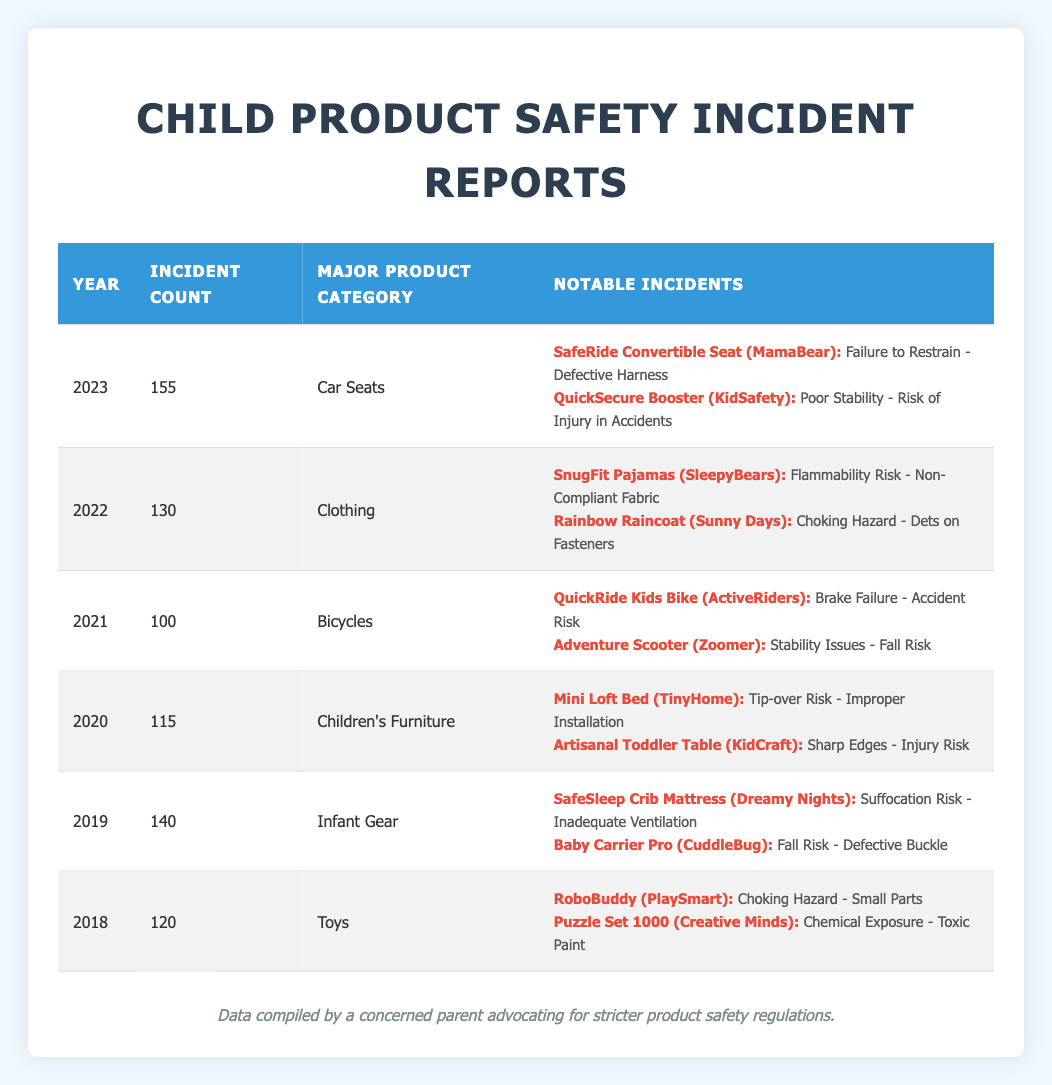What was the incident count for car seats in 2023? In the row for the year 2023, the incident count is listed as 155.
Answer: 155 Which product category had the highest incident count in 2023? The major product category for 2023 is "Car Seats," which had 155 incidents, making it the highest for that year.
Answer: Car Seats How many incident reports were there from 2018 to 2022 combined? To find the total for the years 2018 to 2022, we add the counts: 120 (2018) + 140 (2019) + 115 (2020) + 100 (2021) + 130 (2022) = 705.
Answer: 705 Did any notable incidents in 2021 involve a bicycle? Yes, in 2021, there were two notable incidents regarding bicycles: "QuickRide Kids Bike" and "Adventure Scooter."
Answer: Yes What is the average incident count from 2019 to 2023? We calculate the total incidents from 2019 to 2023: 140 (2019) + 115 (2020) + 100 (2021) + 130 (2022) + 155 (2023) = 640. There are 5 years, so the average is 640 ÷ 5 = 128.
Answer: 128 Which year had the least number of incidents reported? Looking through the data, the year with the least incident count is 2021, with 100 incidents.
Answer: 2021 What type of hazard was associated with the "SafeSleep Crib Mattress"? The notable incident for "SafeSleep Crib Mattress" listed the hazard as "Suffocation Risk - Inadequate Ventilation."
Answer: Suffocation Risk In which product category did the "RoboBuddy" incident occur? The "RoboBuddy" incident is associated with the product category "Toys" for the year 2018.
Answer: Toys What was the change in incident count from 2020 to 2021? The count decreased from 115 incidents in 2020 to 100 incidents in 2021. The change is calculated as 115 - 100 = 15.
Answer: 15 